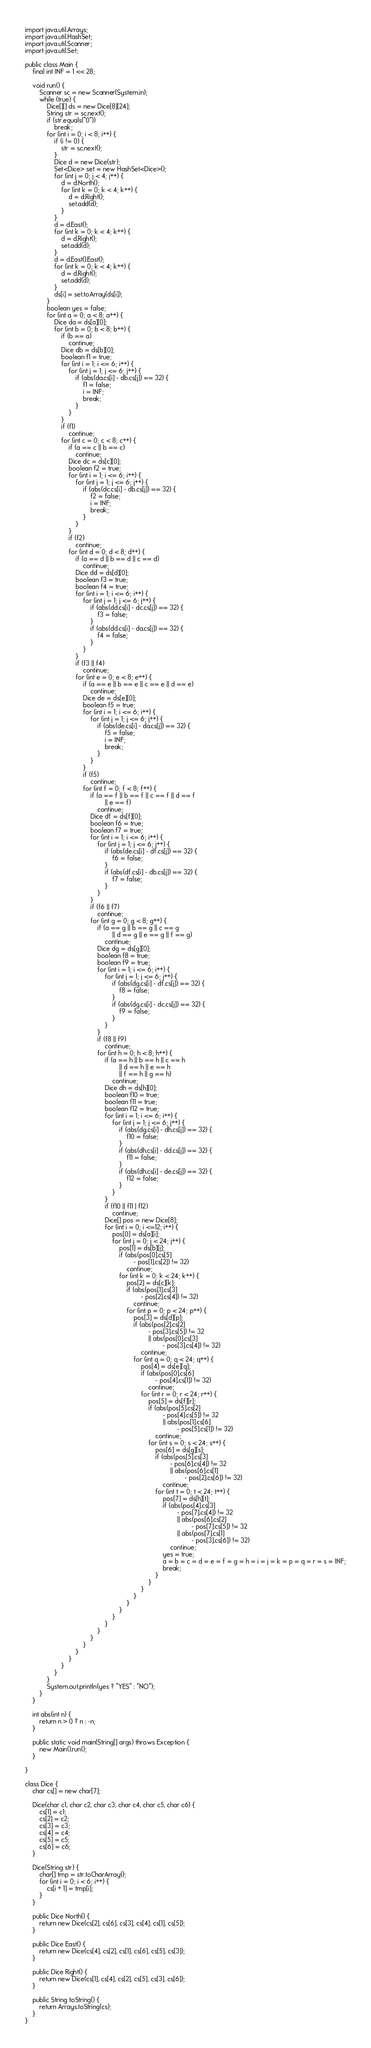Convert code to text. <code><loc_0><loc_0><loc_500><loc_500><_Java_>import java.util.Arrays;
import java.util.HashSet;
import java.util.Scanner;
import java.util.Set;

public class Main {
	final int INF = 1 << 28;

	void run() {
		Scanner sc = new Scanner(System.in);
		while (true) {
			Dice[][] ds = new Dice[8][24];
			String str = sc.next();
			if (str.equals("0"))
				break;
			for (int i = 0; i < 8; i++) {
				if (i != 0) {
					str = sc.next();
				}
				Dice d = new Dice(str);
				Set<Dice> set = new HashSet<Dice>();
				for (int j = 0; j < 4; j++) {
					d = d.North();
					for (int k = 0; k < 4; k++) {
						d = d.Right();
						set.add(d);
					}
				}
				d = d.East();
				for (int k = 0; k < 4; k++) {
					d = d.Right();
					set.add(d);
				}
				d = d.East().East();
				for (int k = 0; k < 4; k++) {
					d = d.Right();
					set.add(d);
				}
				ds[i] = set.toArray(ds[i]);
			}
			boolean yes = false;
			for (int a = 0; a < 8; a++) {
				Dice da = ds[a][0];
				for (int b = 0; b < 8; b++) {
					if (b == a)
						continue;
					Dice db = ds[b][0];
					boolean f1 = true;
					for (int i = 1; i <= 6; i++) {
						for (int j = 1; j <= 6; j++) {
							if (abs(da.cs[i] - db.cs[j]) == 32) {
								f1 = false;
								i = INF;
								break;
							}
						}
					}
					if (f1)
						continue;
					for (int c = 0; c < 8; c++) {
						if (a == c || b == c)
							continue;
						Dice dc = ds[c][0];
						boolean f2 = true;
						for (int i = 1; i <= 6; i++) {
							for (int j = 1; j <= 6; j++) {
								if (abs(dc.cs[i] - db.cs[j]) == 32) {
									f2 = false;
									i = INF;
									break;
								}
							}
						}
						if (f2)
							continue;
						for (int d = 0; d < 8; d++) {
							if (a == d || b == d || c == d)
								continue;
							Dice dd = ds[d][0];
							boolean f3 = true;
							boolean f4 = true;
							for (int i = 1; i <= 6; i++) {
								for (int j = 1; j <= 6; j++) {
									if (abs(dd.cs[i] - dc.cs[j]) == 32) {
										f3 = false;
									}
									if (abs(dd.cs[i] - da.cs[j]) == 32) {
										f4 = false;
									}
								}
							}
							if (f3 || f4)
								continue;
							for (int e = 0; e < 8; e++) {
								if (a == e || b == e || c == e || d == e)
									continue;
								Dice de = ds[e][0];
								boolean f5 = true;
								for (int i = 1; i <= 6; i++) {
									for (int j = 1; j <= 6; j++) {
										if (abs(de.cs[i] - da.cs[j]) == 32) {
											f5 = false;
											i = INF;
											break;
										}
									}
								}
								if (f5)
									continue;
								for (int f = 0; f < 8; f++) {
									if (a == f || b == f || c == f || d == f
											|| e == f)
										continue;
									Dice df = ds[f][0];
									boolean f6 = true;
									boolean f7 = true;
									for (int i = 1; i <= 6; i++) {
										for (int j = 1; j <= 6; j++) {
											if (abs(de.cs[i] - df.cs[j]) == 32) {
												f6 = false;
											}
											if (abs(df.cs[i] - db.cs[j]) == 32) {
												f7 = false;
											}
										}
									}
									if (f6 || f7)
										continue;
									for (int g = 0; g < 8; g++) {
										if (a == g || b == g || c == g
												|| d == g || e == g || f == g)
											continue;
										Dice dg = ds[g][0];
										boolean f8 = true;
										boolean f9 = true;
										for (int i = 1; i <= 6; i++) {
											for (int j = 1; j <= 6; j++) {
												if (abs(dg.cs[i] - df.cs[j]) == 32) {
													f8 = false;
												}
												if (abs(dg.cs[i] - dc.cs[j]) == 32) {
													f9 = false;
												}
											}
										}
										if (f8 || f9)
											continue;
										for (int h = 0; h < 8; h++) {
											if (a == h || b == h || c == h
													|| d == h || e == h
													|| f == h || g == h)
												continue;
											Dice dh = ds[h][0];
											boolean f10 = true;
											boolean f11 = true;
											boolean f12 = true;
											for (int i = 1; i <= 6; i++) {
												for (int j = 1; j <= 6; j++) {
													if (abs(dg.cs[i] - dh.cs[j]) == 32) {
														f10 = false;
													}
													if (abs(dh.cs[i] - dd.cs[j]) == 32) {
														f11 = false;
													}
													if (abs(dh.cs[i] - de.cs[j]) == 32) {
														f12 = false;
													}
												}
											}
											if (f10 || f11 | f12)
												continue;
											Dice[] pos = new Dice[8];
											for (int i = 0; i <=12; i++) {
												pos[0] = ds[a][i];
												for (int j = 0; j < 24; j++) {
													pos[1] = ds[b][j];
													if (abs(pos[0].cs[5]
															- pos[1].cs[2]) != 32)
														continue;
													for (int k = 0; k < 24; k++) {
														pos[2] = ds[c][k];
														if (abs(pos[1].cs[3]
																- pos[2].cs[4]) != 32)
															continue;
														for (int p = 0; p < 24; p++) {
															pos[3] = ds[d][p];
															if (abs(pos[2].cs[2]
																	- pos[3].cs[5]) != 32
																	|| abs(pos[0].cs[3]
																			- pos[3].cs[4]) != 32)
																continue;
															for (int q = 0; q < 24; q++) {
																pos[4] = ds[e][q];
																if (abs(pos[0].cs[6]
																		- pos[4].cs[1]) != 32)
																	continue;
																for (int r = 0; r < 24; r++) {
																	pos[5] = ds[f][r];
																	if (abs(pos[5].cs[2]
																			- pos[4].cs[5]) != 32
																			|| abs(pos[1].cs[6]
																					- pos[5].cs[1]) != 32)
																		continue;
																	for (int s = 0; s < 24; s++) {
																		pos[6] = ds[g][s];
																		if (abs(pos[5].cs[3]
																				- pos[6].cs[4]) != 32
																				|| abs(pos[6].cs[1]
																						- pos[2].cs[6]) != 32)
																			continue;
																		for (int t = 0; t < 24; t++) {
																			pos[7] = ds[h][t];
																			if (abs(pos[4].cs[3]
																					- pos[7].cs[4]) != 32
																					|| abs(pos[6].cs[2]
																							- pos[7].cs[5]) != 32
																					|| abs(pos[7].cs[1]
																							- pos[3].cs[6]) != 32)
																				continue;
																			yes = true;
																			a = b = c = d = e = f = g = h = i = j = k = p = q = r = s = INF;
																			break;
																		}
																	}
																}
															}
														}
													}
												}
											}
										}
									}
								}
							}
						}
					}
				}
			}
			System.out.println(yes ? "YES" : "NO");
		}
	}

	int abs(int n) {
		return n > 0 ? n : -n;
	}

	public static void main(String[] args) throws Exception {
		new Main().run();
	}

}

class Dice {
	char cs[] = new char[7];

	Dice(char c1, char c2, char c3, char c4, char c5, char c6) {
		cs[1] = c1;
		cs[2] = c2;
		cs[3] = c3;
		cs[4] = c4;
		cs[5] = c5;
		cs[6] = c6;
	}

	Dice(String str) {
		char[] tmp = str.toCharArray();
		for (int i = 0; i < 6; i++) {
			cs[i + 1] = tmp[i];
		}
	}

	public Dice North() {
		return new Dice(cs[2], cs[6], cs[3], cs[4], cs[1], cs[5]);
	}

	public Dice East() {
		return new Dice(cs[4], cs[2], cs[1], cs[6], cs[5], cs[3]);
	}

	public Dice Right() {
		return new Dice(cs[1], cs[4], cs[2], cs[5], cs[3], cs[6]);
	}

	public String toString() {
		return Arrays.toString(cs);
	}
}</code> 